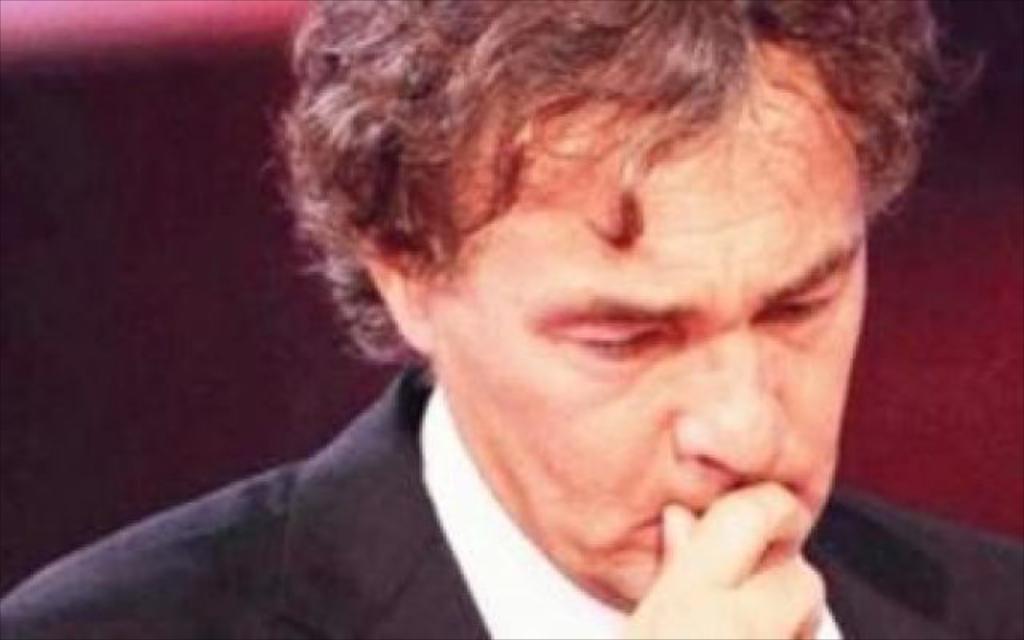In one or two sentences, can you explain what this image depicts? In this image in the foreground there is one person, and the background is blurred. 